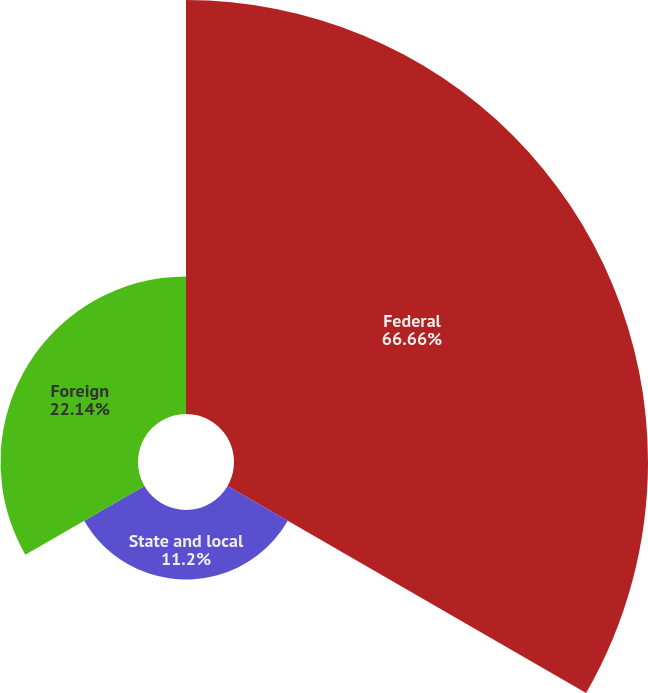<chart> <loc_0><loc_0><loc_500><loc_500><pie_chart><fcel>Federal<fcel>State and local<fcel>Foreign<nl><fcel>66.67%<fcel>11.2%<fcel>22.14%<nl></chart> 